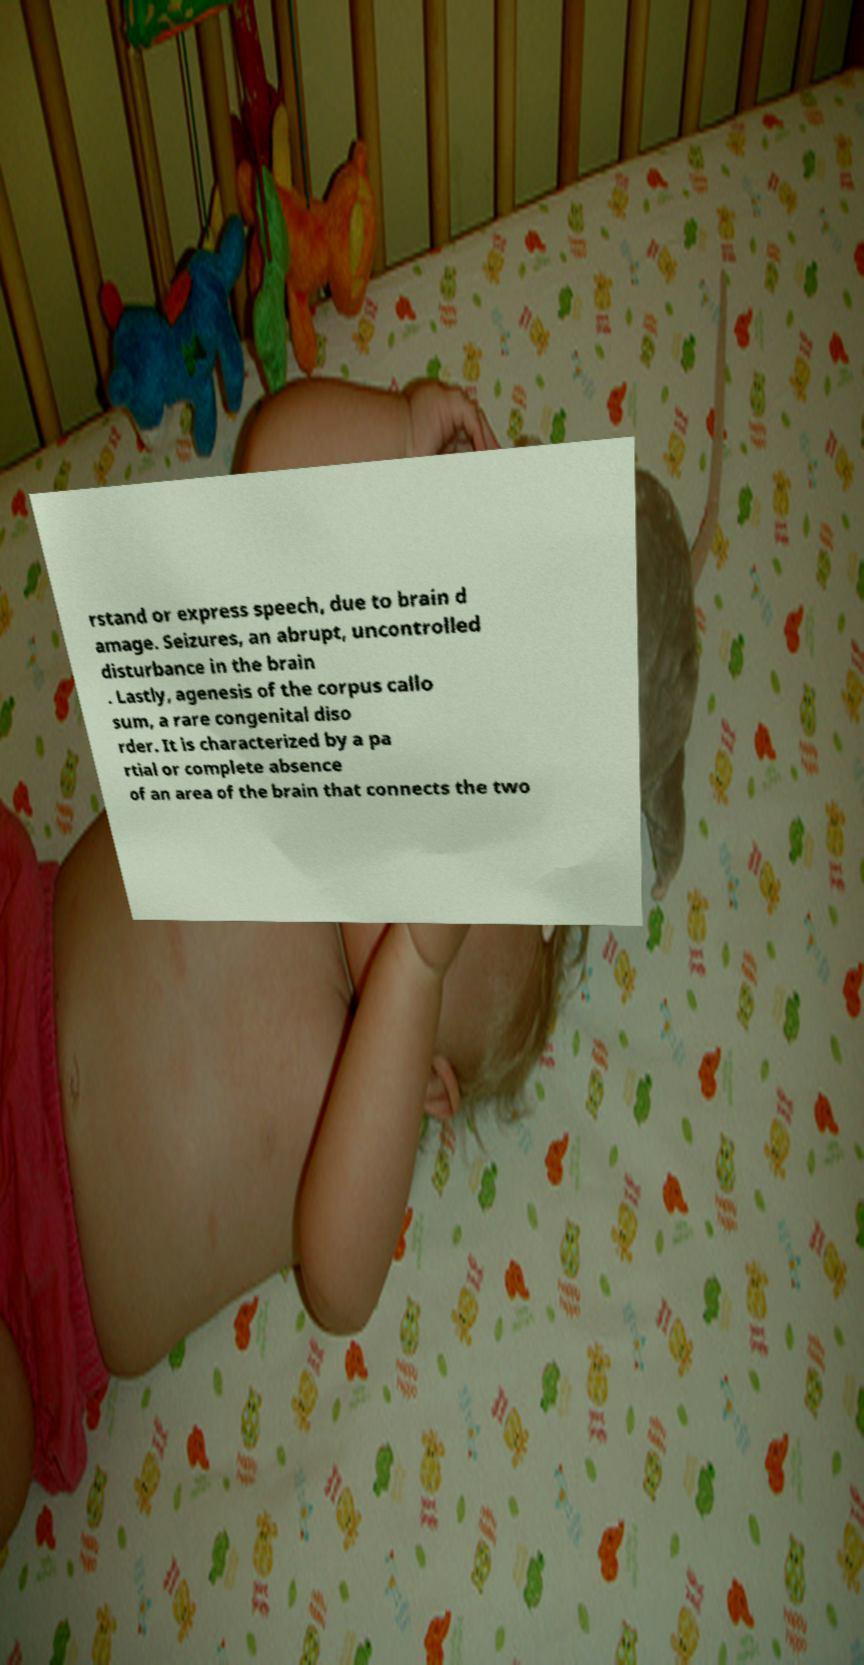There's text embedded in this image that I need extracted. Can you transcribe it verbatim? rstand or express speech, due to brain d amage. Seizures, an abrupt, uncontrolled disturbance in the brain . Lastly, agenesis of the corpus callo sum, a rare congenital diso rder. It is characterized by a pa rtial or complete absence of an area of the brain that connects the two 